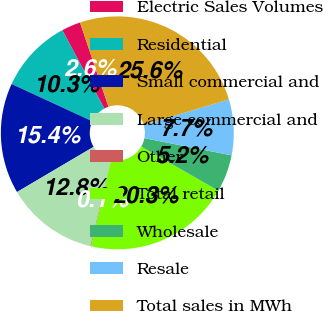Convert chart. <chart><loc_0><loc_0><loc_500><loc_500><pie_chart><fcel>Electric Sales Volumes<fcel>Residential<fcel>Small commercial and<fcel>Large commercial and<fcel>Other<fcel>Total retail<fcel>Wholesale<fcel>Resale<fcel>Total sales in MWh<nl><fcel>2.64%<fcel>10.28%<fcel>15.37%<fcel>12.82%<fcel>0.09%<fcel>20.33%<fcel>5.18%<fcel>7.73%<fcel>25.55%<nl></chart> 